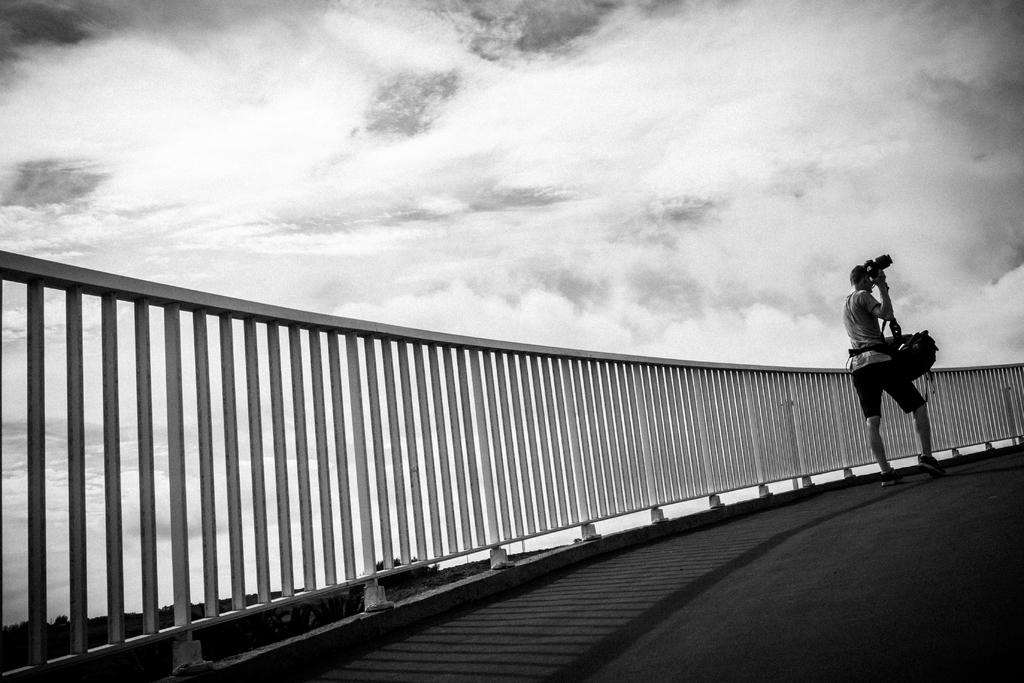What is the person in the image doing? The person is walking in the image. What is the person wearing while walking? The person is wearing clothes and shoes. What object is the person holding in their hand? The person is holding a camera in their hand. What can be seen in the background of the image? There is a fence and a road in the background of the image. What is the weather like in the image? The sky is cloudy in the image. Can you tell me how many crooks are present in the image? There are no crooks present in the image; it features a person walking with a camera. What type of harmony can be heard in the image? There is no sound or music present in the image, so it is not possible to determine the type of harmony. 